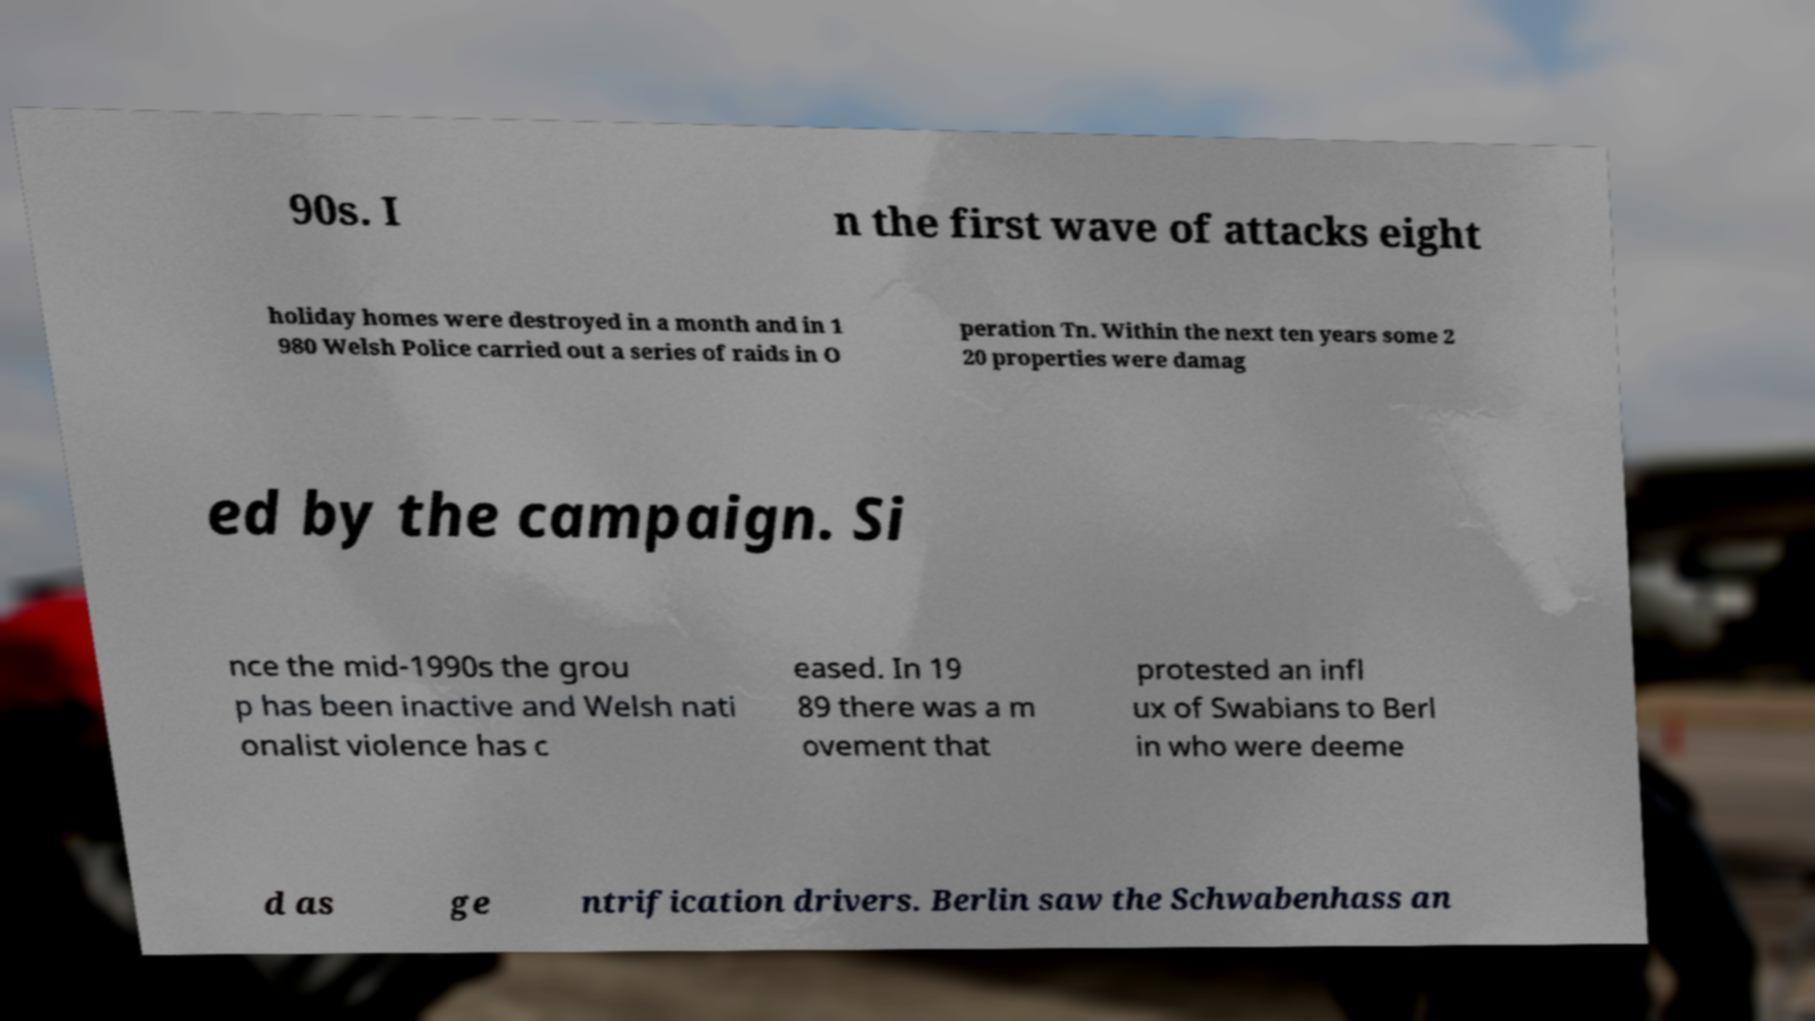Can you read and provide the text displayed in the image?This photo seems to have some interesting text. Can you extract and type it out for me? 90s. I n the first wave of attacks eight holiday homes were destroyed in a month and in 1 980 Welsh Police carried out a series of raids in O peration Tn. Within the next ten years some 2 20 properties were damag ed by the campaign. Si nce the mid-1990s the grou p has been inactive and Welsh nati onalist violence has c eased. In 19 89 there was a m ovement that protested an infl ux of Swabians to Berl in who were deeme d as ge ntrification drivers. Berlin saw the Schwabenhass an 